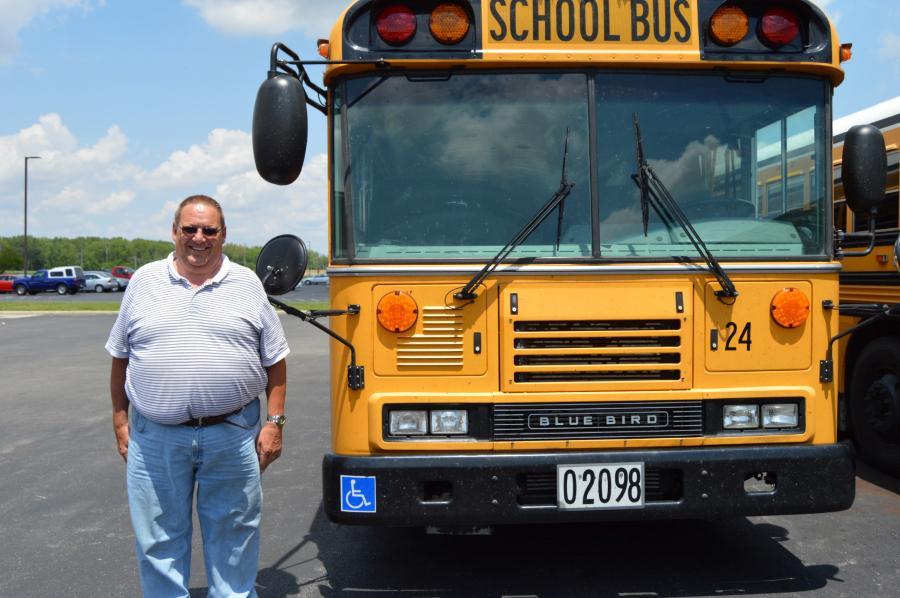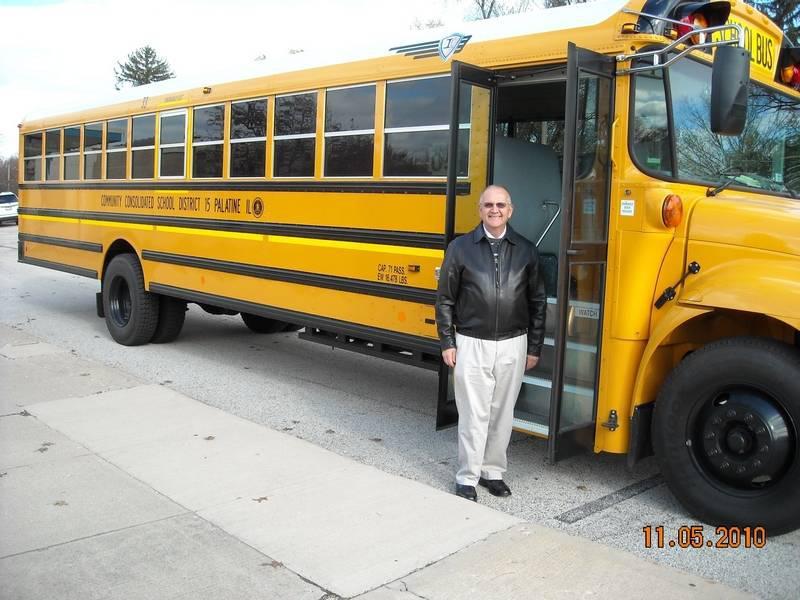The first image is the image on the left, the second image is the image on the right. Evaluate the accuracy of this statement regarding the images: "One image shows one forward-facing flat-fronted bus with at least one person standing at the left, door side, and the other image shows a forward-facing non-flat-front bus with at least one person standing at the left, door side.". Is it true? Answer yes or no. Yes. The first image is the image on the left, the second image is the image on the right. Considering the images on both sides, is "In the image to the right, at least one person is standing in front of the open door to the bus." valid? Answer yes or no. Yes. 